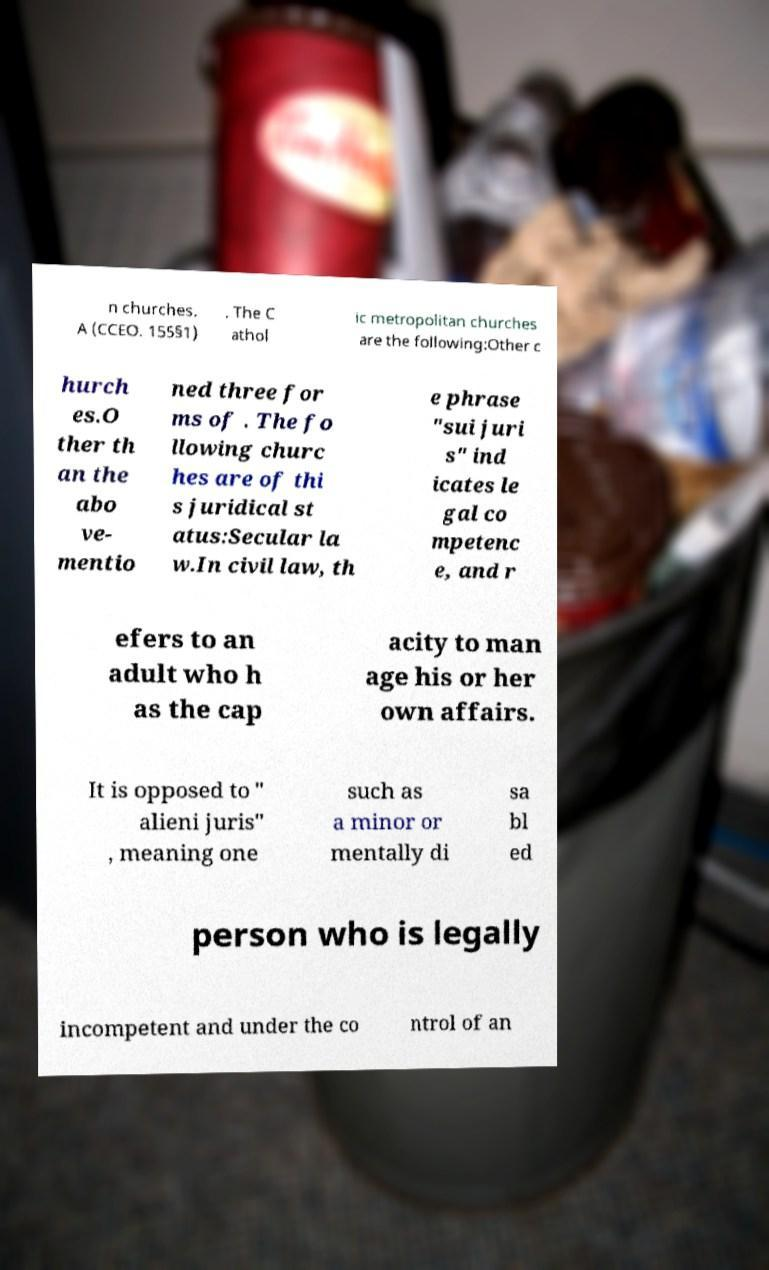Please read and relay the text visible in this image. What does it say? n churches. A (CCEO. 155§1) . The C athol ic metropolitan churches are the following:Other c hurch es.O ther th an the abo ve- mentio ned three for ms of . The fo llowing churc hes are of thi s juridical st atus:Secular la w.In civil law, th e phrase "sui juri s" ind icates le gal co mpetenc e, and r efers to an adult who h as the cap acity to man age his or her own affairs. It is opposed to " alieni juris" , meaning one such as a minor or mentally di sa bl ed person who is legally incompetent and under the co ntrol of an 